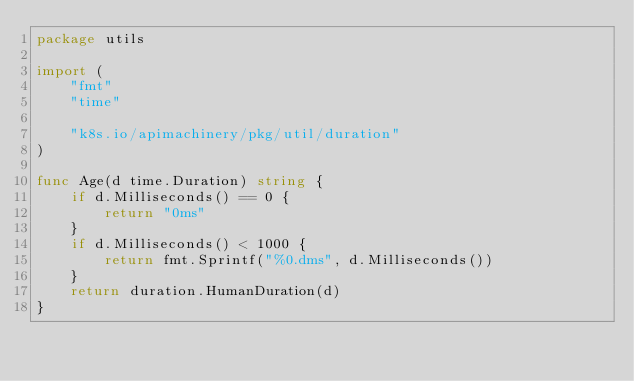Convert code to text. <code><loc_0><loc_0><loc_500><loc_500><_Go_>package utils

import (
	"fmt"
	"time"

	"k8s.io/apimachinery/pkg/util/duration"
)

func Age(d time.Duration) string {
	if d.Milliseconds() == 0 {
		return "0ms"
	}
	if d.Milliseconds() < 1000 {
		return fmt.Sprintf("%0.dms", d.Milliseconds())
	}
	return duration.HumanDuration(d)
}
</code> 